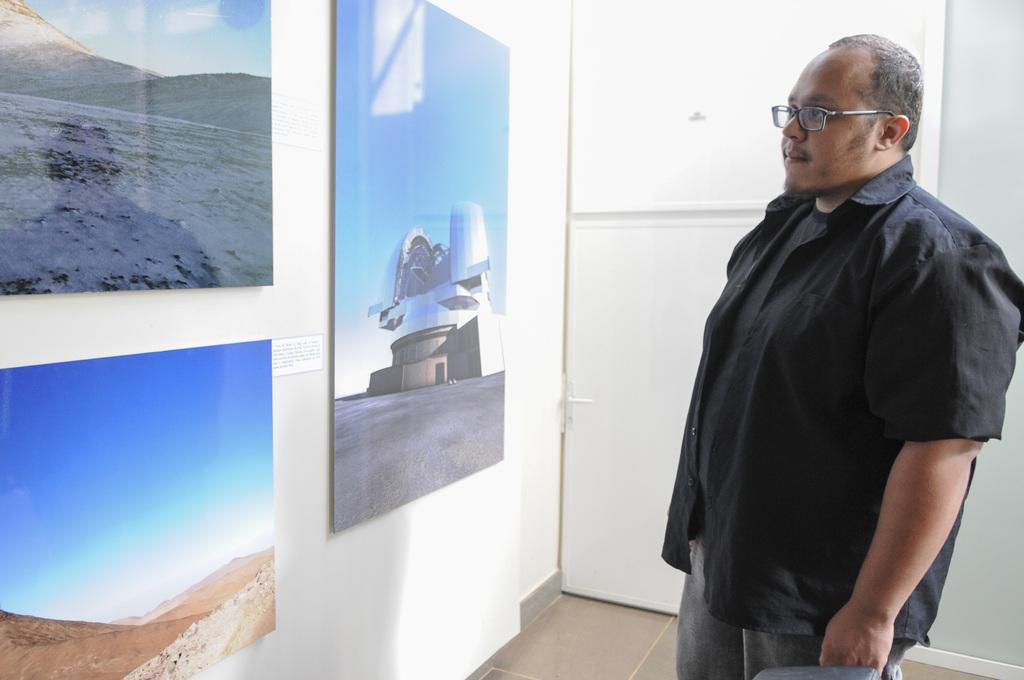What is the main subject of the image? There is a person standing in the image. Can you describe the person's appearance? The person is wearing spectacles. What can be seen on the wall in the image? There are photo frames on the wall. Is there any architectural feature visible in the image? Yes, there is a door in the image. How does the earthquake affect the person in the image? There is no earthquake present in the image, so its effects cannot be observed. What is the weight of the person's uncle in the image? There is no uncle present in the image, so their weight cannot be determined. 